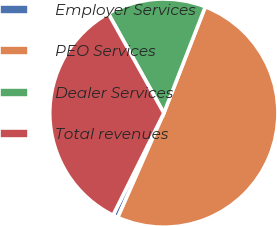Convert chart to OTSL. <chart><loc_0><loc_0><loc_500><loc_500><pie_chart><fcel>Employer Services<fcel>PEO Services<fcel>Dealer Services<fcel>Total revenues<nl><fcel>0.74%<fcel>50.7%<fcel>14.01%<fcel>34.56%<nl></chart> 